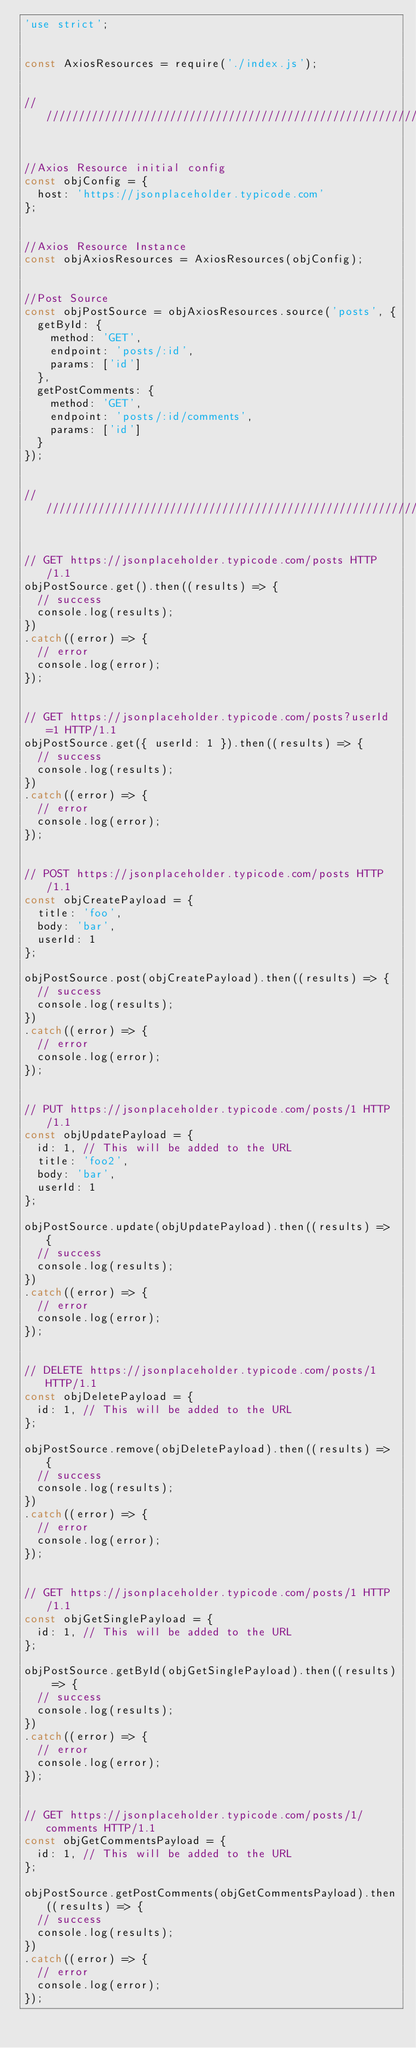Convert code to text. <code><loc_0><loc_0><loc_500><loc_500><_JavaScript_>'use strict';


const AxiosResources = require('./index.js');


////////////////////////////////////////////////////////////


//Axios Resource initial config
const objConfig = {
  host: 'https://jsonplaceholder.typicode.com'
};


//Axios Resource Instance
const objAxiosResources = AxiosResources(objConfig);


//Post Source
const objPostSource = objAxiosResources.source('posts', {
  getById: {
    method: 'GET',
    endpoint: 'posts/:id',
    params: ['id']
  },
  getPostComments: {
    method: 'GET',
    endpoint: 'posts/:id/comments',
    params: ['id']
  }
});


////////////////////////////////////////////////////////////


// GET https://jsonplaceholder.typicode.com/posts HTTP/1.1
objPostSource.get().then((results) => {
  // success
  console.log(results);
})
.catch((error) => {
  // error
  console.log(error);
});


// GET https://jsonplaceholder.typicode.com/posts?userId=1 HTTP/1.1
objPostSource.get({ userId: 1 }).then((results) => {
  // success
  console.log(results);
})
.catch((error) => {
  // error
  console.log(error);
});


// POST https://jsonplaceholder.typicode.com/posts HTTP/1.1
const objCreatePayload = {
  title: 'foo',
  body: 'bar',
  userId: 1
};

objPostSource.post(objCreatePayload).then((results) => {
  // success
  console.log(results);
})
.catch((error) => {
  // error
  console.log(error);
});


// PUT https://jsonplaceholder.typicode.com/posts/1 HTTP/1.1
const objUpdatePayload = {
  id: 1, // This will be added to the URL
  title: 'foo2',
  body: 'bar',
  userId: 1
};

objPostSource.update(objUpdatePayload).then((results) => {
  // success
  console.log(results);
})
.catch((error) => {
  // error
  console.log(error);
});


// DELETE https://jsonplaceholder.typicode.com/posts/1 HTTP/1.1
const objDeletePayload = {
  id: 1, // This will be added to the URL
};

objPostSource.remove(objDeletePayload).then((results) => {
  // success
  console.log(results);
})
.catch((error) => {
  // error
  console.log(error);
});


// GET https://jsonplaceholder.typicode.com/posts/1 HTTP/1.1
const objGetSinglePayload = {
  id: 1, // This will be added to the URL
};

objPostSource.getById(objGetSinglePayload).then((results) => {
  // success
  console.log(results);
})
.catch((error) => {
  // error
  console.log(error);
});


// GET https://jsonplaceholder.typicode.com/posts/1/comments HTTP/1.1
const objGetCommentsPayload = {
  id: 1, // This will be added to the URL
};

objPostSource.getPostComments(objGetCommentsPayload).then((results) => {
  // success
  console.log(results);
})
.catch((error) => {
  // error
  console.log(error);
});
</code> 